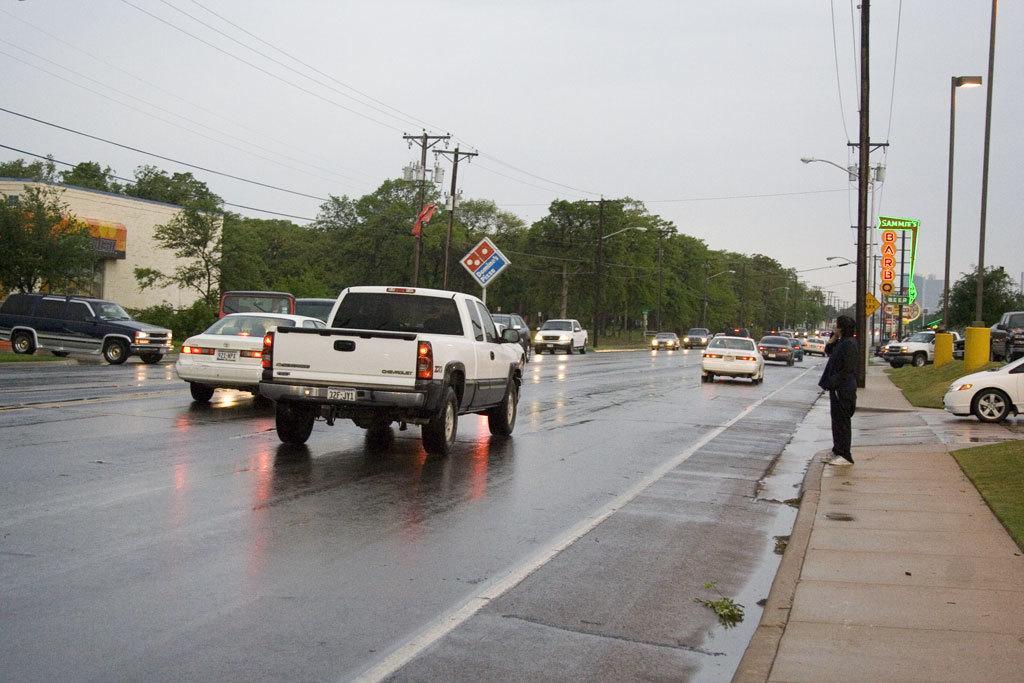Describe this image in one or two sentences. In the background we can see the sky. In this picture we can see the trees, poles, lights, transmission wires, objects, vehicles, boards. On the left side of the picture we can see the wall. On the right side of the picture we can see a person is standing. We can see grass. We can see the road is wet. 